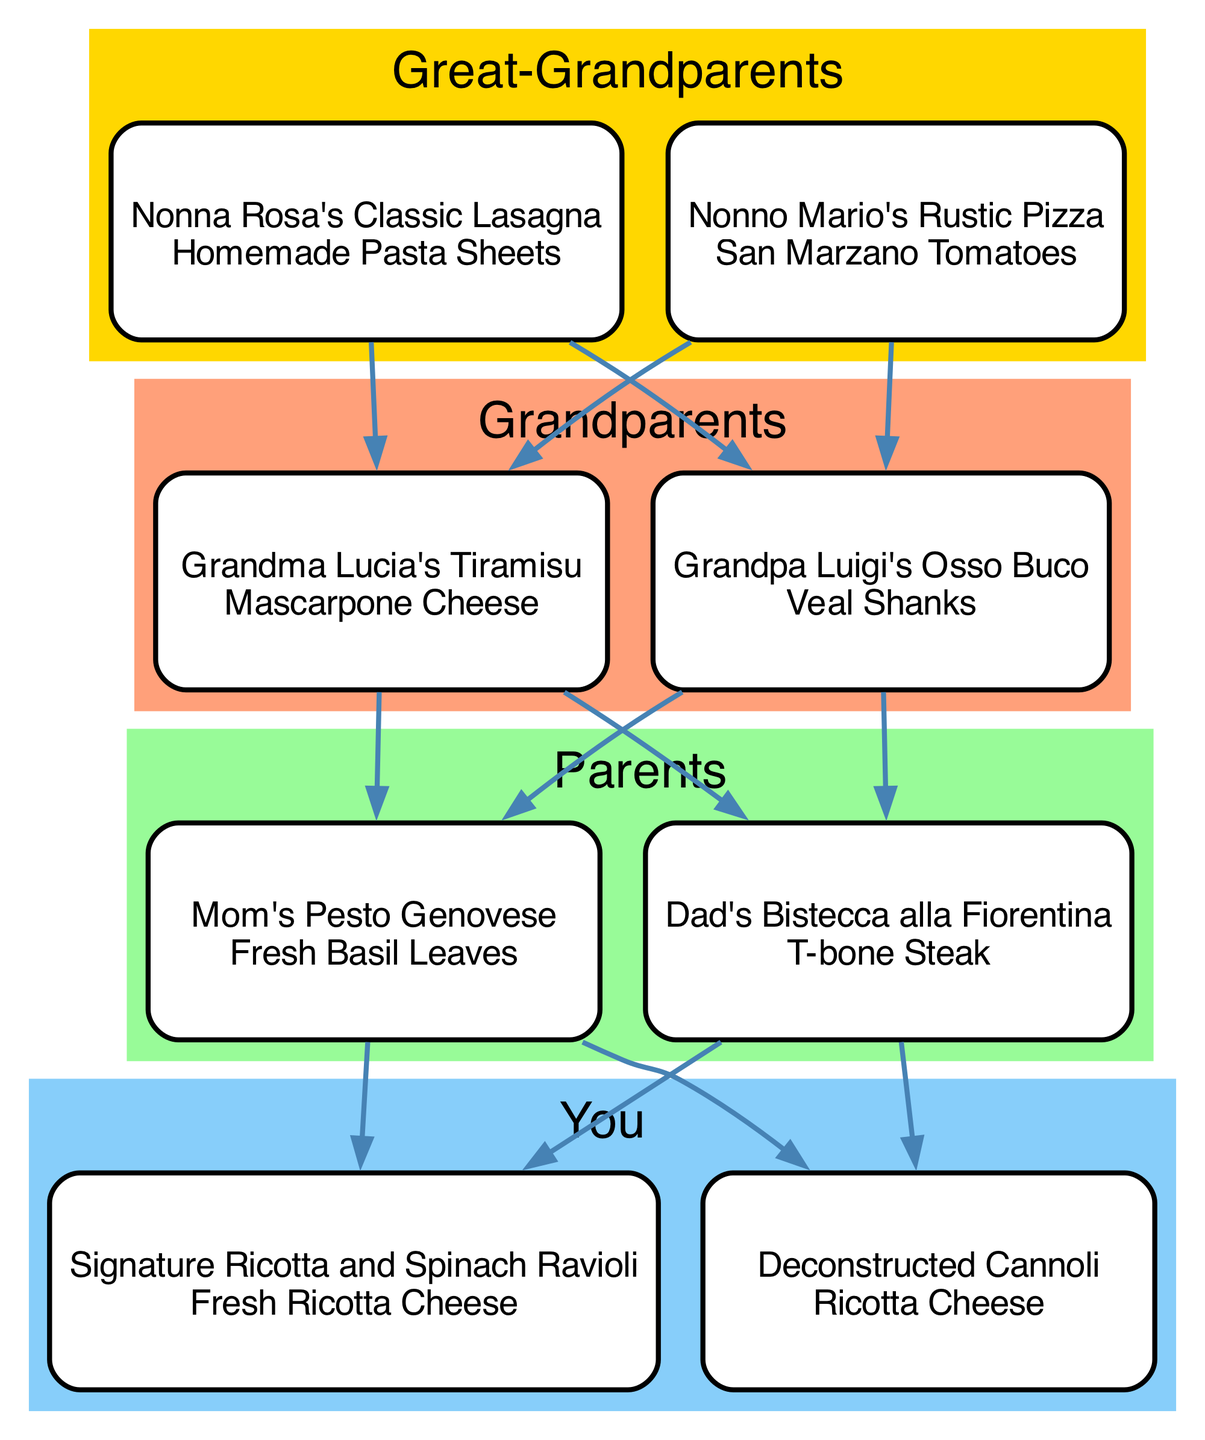What culinary dish did Great-Grandma Rosa create? The diagram shows that Great-Grandma Rosa's signature dish is listed as "Nonna Rosa's Classic Lasagna." Therefore, the answer is found directly under the Great-Grandparents generation node.
Answer: Nonna Rosa's Classic Lasagna How many culinary dishes are associated with the Grandparents generation? By reviewing the Grandparents generation node in the diagram, we see there are two culinary dishes listed: "Grandma Lucia's Tiramisu" and "Grandpa Luigi's Osso Buco." This means there are two dishes in total.
Answer: 2 What is the signature ingredient of Dad's dish? Looking at the Parents generation, Dad's signature dish is "Dad's Bistecca alla Fiorentina," which has "T-bone Steak" listed as its signature ingredient. This can be found by checking directly under that dish’s name in the diagram.
Answer: T-bone Steak Which dish is connected to Grandma Lucia's Tiramisu? The diagram illustrates that "Grandma Lucia's Tiramisu" connects to both "Mom's Pesto Genovese" and "Dad's Bistecca alla Fiorentina." This connection indicates that these dishes are part of the next generation, showing influence or evolution in culinary tradition.
Answer: Mom's Pesto Genovese, Dad's Bistecca alla Fiorentina What is the relationship between Nonno Mario's Rustic Pizza and Signature Ricotta and Spinach Ravioli? The diagram shows that "Nonno Mario's Rustic Pizza," from the Great-Grandparents generation, connects to "Signature Ricotta and Spinach Ravioli," which is your dish. This connection illustrates the culinary lineage from Nonno Mario to you through the generations, indicating a direct influence.
Answer: Culinary lineage Which generation features a dessert dish? The diagram indicates that both the Grandparents and your generation contain dessert dishes. Grandma Lucia's Tiramisu is present in the Grandparents generation, and "Deconstructed Cannoli" is found in your generation. Since both have dessert dishes, the answer is both generations.
Answer: Grandparents, You How many generations are represented in the diagram? By examining the nodes, we see there are four distinct generations present: Great-Grandparents, Grandparents, Parents, and your generation. The count of these nodes directly provides the number of generations depicted in the diagram.
Answer: 4 What is the signature ingredient of Grandma Lucia's Tiramisu? From the diagram, Grandma Lucia's Tiramisu has "Mascarpone Cheese" listed as its signature ingredient. This can be easily retrieved from the details under her dish's name.
Answer: Mascarpone Cheese 